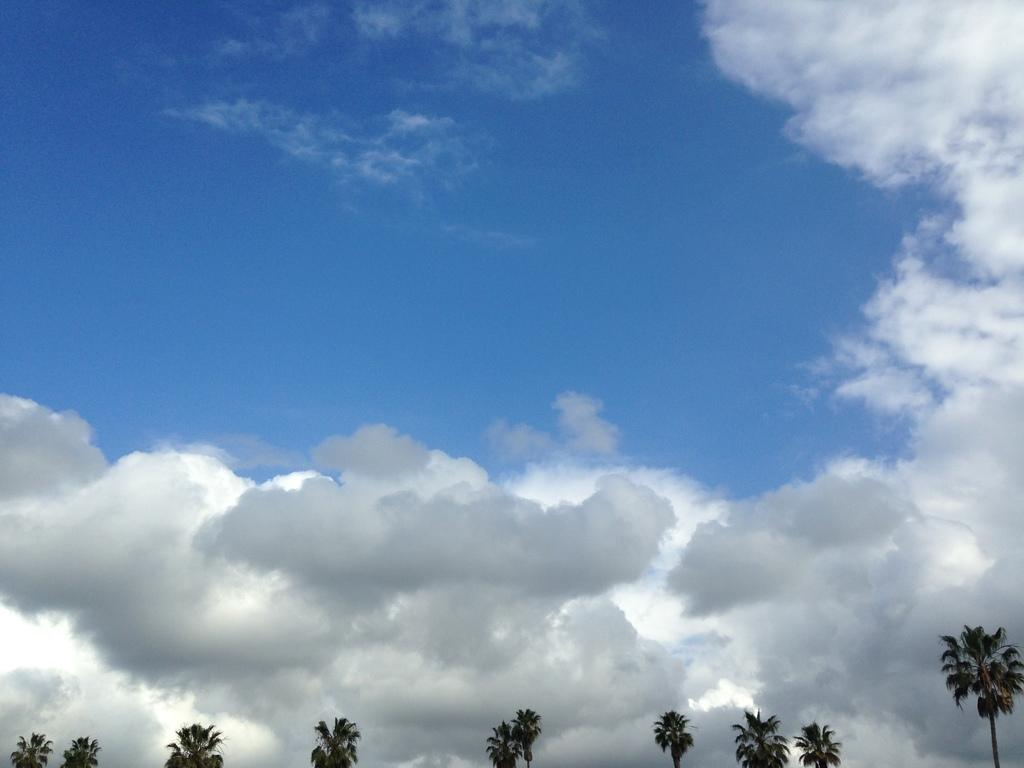What type of vegetation can be seen in the image? There are trees in the image. What is the condition of the sky in the image? The sky is cloudy in the image. What is the surprise element in the image? There is no surprise element mentioned or depicted in the image, as it only features trees and a cloudy sky. 